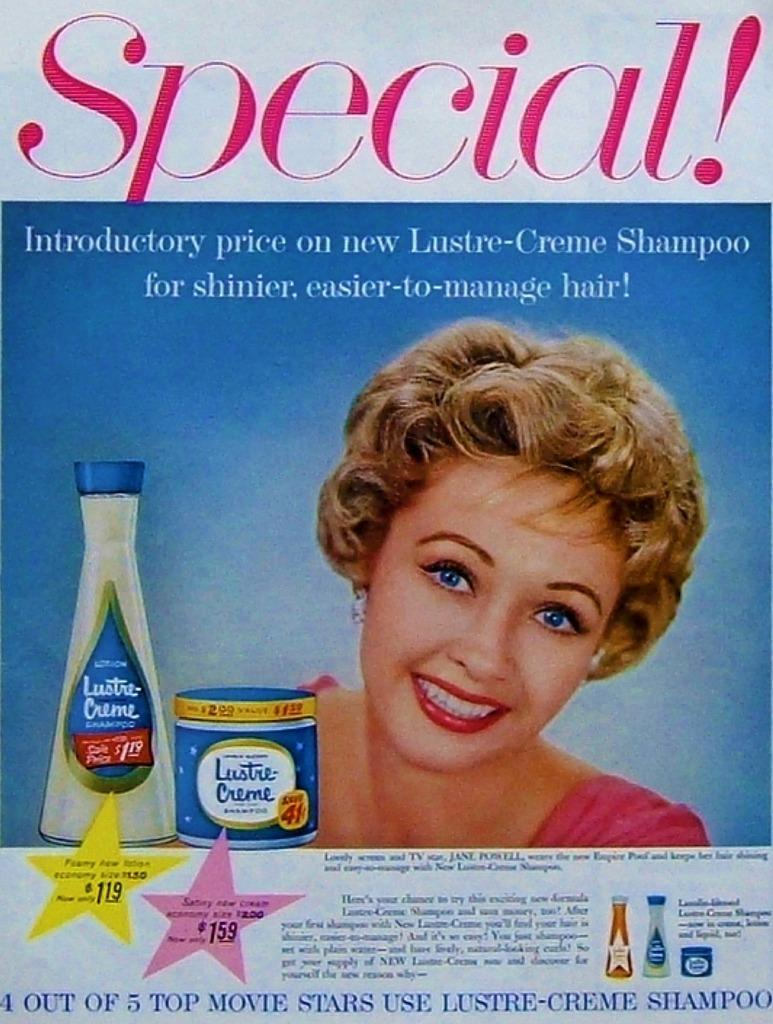<image>
Summarize the visual content of the image. An advertisement for Lustre-Creme shampoo with a price of $1.19. 